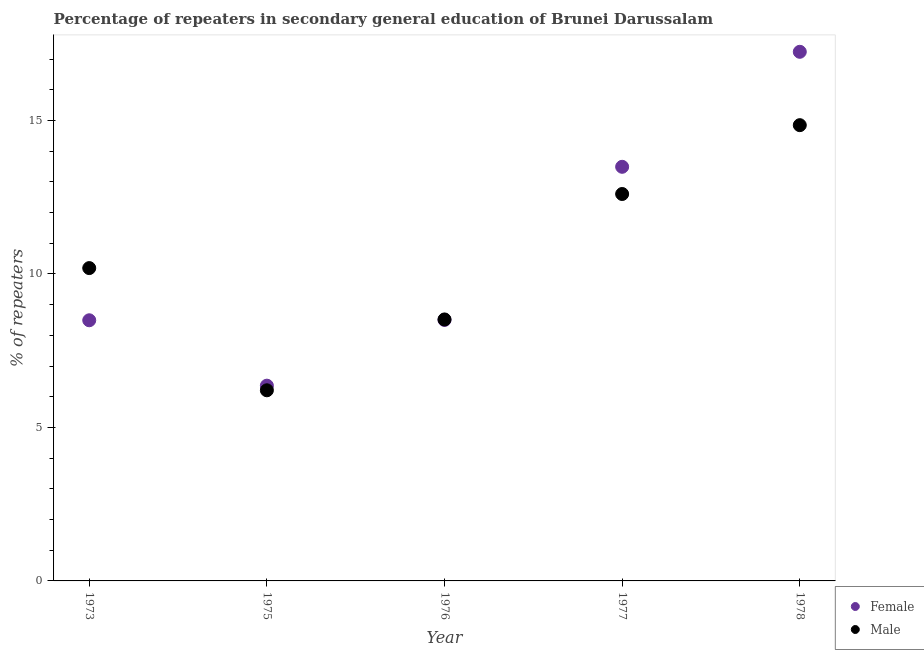Is the number of dotlines equal to the number of legend labels?
Make the answer very short. Yes. What is the percentage of male repeaters in 1975?
Keep it short and to the point. 6.21. Across all years, what is the maximum percentage of male repeaters?
Your response must be concise. 14.85. Across all years, what is the minimum percentage of female repeaters?
Provide a short and direct response. 6.36. In which year was the percentage of female repeaters maximum?
Your response must be concise. 1978. In which year was the percentage of female repeaters minimum?
Give a very brief answer. 1975. What is the total percentage of male repeaters in the graph?
Your response must be concise. 52.37. What is the difference between the percentage of female repeaters in 1976 and that in 1977?
Offer a terse response. -4.99. What is the difference between the percentage of male repeaters in 1977 and the percentage of female repeaters in 1973?
Give a very brief answer. 4.11. What is the average percentage of female repeaters per year?
Ensure brevity in your answer.  10.82. In the year 1975, what is the difference between the percentage of male repeaters and percentage of female repeaters?
Offer a terse response. -0.15. In how many years, is the percentage of male repeaters greater than 7 %?
Offer a very short reply. 4. What is the ratio of the percentage of female repeaters in 1976 to that in 1977?
Offer a terse response. 0.63. Is the percentage of female repeaters in 1975 less than that in 1976?
Your answer should be compact. Yes. What is the difference between the highest and the second highest percentage of female repeaters?
Your response must be concise. 3.75. What is the difference between the highest and the lowest percentage of female repeaters?
Ensure brevity in your answer.  10.88. In how many years, is the percentage of male repeaters greater than the average percentage of male repeaters taken over all years?
Offer a terse response. 2. Is the sum of the percentage of female repeaters in 1976 and 1978 greater than the maximum percentage of male repeaters across all years?
Give a very brief answer. Yes. Does the percentage of female repeaters monotonically increase over the years?
Give a very brief answer. No. Is the percentage of female repeaters strictly greater than the percentage of male repeaters over the years?
Make the answer very short. No. Are the values on the major ticks of Y-axis written in scientific E-notation?
Your response must be concise. No. Where does the legend appear in the graph?
Ensure brevity in your answer.  Bottom right. What is the title of the graph?
Offer a very short reply. Percentage of repeaters in secondary general education of Brunei Darussalam. What is the label or title of the X-axis?
Your answer should be very brief. Year. What is the label or title of the Y-axis?
Offer a terse response. % of repeaters. What is the % of repeaters in Female in 1973?
Offer a very short reply. 8.49. What is the % of repeaters in Male in 1973?
Make the answer very short. 10.19. What is the % of repeaters of Female in 1975?
Your answer should be compact. 6.36. What is the % of repeaters in Male in 1975?
Make the answer very short. 6.21. What is the % of repeaters of Female in 1976?
Your response must be concise. 8.5. What is the % of repeaters in Male in 1976?
Offer a terse response. 8.52. What is the % of repeaters in Female in 1977?
Offer a very short reply. 13.49. What is the % of repeaters of Male in 1977?
Your answer should be compact. 12.6. What is the % of repeaters of Female in 1978?
Keep it short and to the point. 17.24. What is the % of repeaters in Male in 1978?
Give a very brief answer. 14.85. Across all years, what is the maximum % of repeaters of Female?
Your answer should be compact. 17.24. Across all years, what is the maximum % of repeaters of Male?
Ensure brevity in your answer.  14.85. Across all years, what is the minimum % of repeaters in Female?
Ensure brevity in your answer.  6.36. Across all years, what is the minimum % of repeaters in Male?
Provide a short and direct response. 6.21. What is the total % of repeaters of Female in the graph?
Provide a short and direct response. 54.08. What is the total % of repeaters of Male in the graph?
Provide a succinct answer. 52.37. What is the difference between the % of repeaters of Female in 1973 and that in 1975?
Make the answer very short. 2.13. What is the difference between the % of repeaters of Male in 1973 and that in 1975?
Provide a short and direct response. 3.98. What is the difference between the % of repeaters in Female in 1973 and that in 1976?
Offer a terse response. -0.01. What is the difference between the % of repeaters of Male in 1973 and that in 1976?
Provide a short and direct response. 1.67. What is the difference between the % of repeaters of Female in 1973 and that in 1977?
Provide a succinct answer. -5. What is the difference between the % of repeaters in Male in 1973 and that in 1977?
Ensure brevity in your answer.  -2.41. What is the difference between the % of repeaters in Female in 1973 and that in 1978?
Offer a terse response. -8.75. What is the difference between the % of repeaters in Male in 1973 and that in 1978?
Your response must be concise. -4.66. What is the difference between the % of repeaters of Female in 1975 and that in 1976?
Offer a very short reply. -2.14. What is the difference between the % of repeaters in Male in 1975 and that in 1976?
Provide a short and direct response. -2.31. What is the difference between the % of repeaters in Female in 1975 and that in 1977?
Keep it short and to the point. -7.13. What is the difference between the % of repeaters of Male in 1975 and that in 1977?
Offer a very short reply. -6.39. What is the difference between the % of repeaters of Female in 1975 and that in 1978?
Provide a succinct answer. -10.88. What is the difference between the % of repeaters in Male in 1975 and that in 1978?
Offer a very short reply. -8.64. What is the difference between the % of repeaters of Female in 1976 and that in 1977?
Give a very brief answer. -4.99. What is the difference between the % of repeaters in Male in 1976 and that in 1977?
Make the answer very short. -4.09. What is the difference between the % of repeaters of Female in 1976 and that in 1978?
Offer a very short reply. -8.74. What is the difference between the % of repeaters in Male in 1976 and that in 1978?
Give a very brief answer. -6.33. What is the difference between the % of repeaters of Female in 1977 and that in 1978?
Your answer should be compact. -3.75. What is the difference between the % of repeaters of Male in 1977 and that in 1978?
Give a very brief answer. -2.24. What is the difference between the % of repeaters of Female in 1973 and the % of repeaters of Male in 1975?
Ensure brevity in your answer.  2.28. What is the difference between the % of repeaters in Female in 1973 and the % of repeaters in Male in 1976?
Your response must be concise. -0.03. What is the difference between the % of repeaters of Female in 1973 and the % of repeaters of Male in 1977?
Give a very brief answer. -4.11. What is the difference between the % of repeaters of Female in 1973 and the % of repeaters of Male in 1978?
Offer a very short reply. -6.36. What is the difference between the % of repeaters of Female in 1975 and the % of repeaters of Male in 1976?
Give a very brief answer. -2.16. What is the difference between the % of repeaters of Female in 1975 and the % of repeaters of Male in 1977?
Your response must be concise. -6.24. What is the difference between the % of repeaters in Female in 1975 and the % of repeaters in Male in 1978?
Ensure brevity in your answer.  -8.49. What is the difference between the % of repeaters in Female in 1976 and the % of repeaters in Male in 1977?
Offer a terse response. -4.1. What is the difference between the % of repeaters of Female in 1976 and the % of repeaters of Male in 1978?
Give a very brief answer. -6.35. What is the difference between the % of repeaters in Female in 1977 and the % of repeaters in Male in 1978?
Your answer should be very brief. -1.36. What is the average % of repeaters of Female per year?
Make the answer very short. 10.82. What is the average % of repeaters of Male per year?
Your answer should be very brief. 10.47. In the year 1973, what is the difference between the % of repeaters of Female and % of repeaters of Male?
Keep it short and to the point. -1.7. In the year 1975, what is the difference between the % of repeaters of Female and % of repeaters of Male?
Your answer should be very brief. 0.15. In the year 1976, what is the difference between the % of repeaters of Female and % of repeaters of Male?
Your response must be concise. -0.02. In the year 1977, what is the difference between the % of repeaters in Female and % of repeaters in Male?
Keep it short and to the point. 0.89. In the year 1978, what is the difference between the % of repeaters of Female and % of repeaters of Male?
Provide a short and direct response. 2.39. What is the ratio of the % of repeaters in Female in 1973 to that in 1975?
Provide a succinct answer. 1.33. What is the ratio of the % of repeaters of Male in 1973 to that in 1975?
Your answer should be very brief. 1.64. What is the ratio of the % of repeaters of Female in 1973 to that in 1976?
Your answer should be very brief. 1. What is the ratio of the % of repeaters of Male in 1973 to that in 1976?
Offer a terse response. 1.2. What is the ratio of the % of repeaters of Female in 1973 to that in 1977?
Your response must be concise. 0.63. What is the ratio of the % of repeaters in Male in 1973 to that in 1977?
Make the answer very short. 0.81. What is the ratio of the % of repeaters in Female in 1973 to that in 1978?
Your answer should be compact. 0.49. What is the ratio of the % of repeaters of Male in 1973 to that in 1978?
Your answer should be compact. 0.69. What is the ratio of the % of repeaters of Female in 1975 to that in 1976?
Ensure brevity in your answer.  0.75. What is the ratio of the % of repeaters of Male in 1975 to that in 1976?
Offer a very short reply. 0.73. What is the ratio of the % of repeaters of Female in 1975 to that in 1977?
Your answer should be very brief. 0.47. What is the ratio of the % of repeaters of Male in 1975 to that in 1977?
Offer a very short reply. 0.49. What is the ratio of the % of repeaters of Female in 1975 to that in 1978?
Your answer should be compact. 0.37. What is the ratio of the % of repeaters of Male in 1975 to that in 1978?
Make the answer very short. 0.42. What is the ratio of the % of repeaters of Female in 1976 to that in 1977?
Give a very brief answer. 0.63. What is the ratio of the % of repeaters in Male in 1976 to that in 1977?
Ensure brevity in your answer.  0.68. What is the ratio of the % of repeaters in Female in 1976 to that in 1978?
Give a very brief answer. 0.49. What is the ratio of the % of repeaters of Male in 1976 to that in 1978?
Keep it short and to the point. 0.57. What is the ratio of the % of repeaters in Female in 1977 to that in 1978?
Provide a succinct answer. 0.78. What is the ratio of the % of repeaters in Male in 1977 to that in 1978?
Offer a very short reply. 0.85. What is the difference between the highest and the second highest % of repeaters in Female?
Provide a short and direct response. 3.75. What is the difference between the highest and the second highest % of repeaters of Male?
Offer a very short reply. 2.24. What is the difference between the highest and the lowest % of repeaters of Female?
Offer a very short reply. 10.88. What is the difference between the highest and the lowest % of repeaters of Male?
Provide a succinct answer. 8.64. 